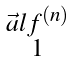<formula> <loc_0><loc_0><loc_500><loc_500>\begin{smallmatrix} \vec { a } l f ^ { ( n ) } \\ 1 \end{smallmatrix}</formula> 